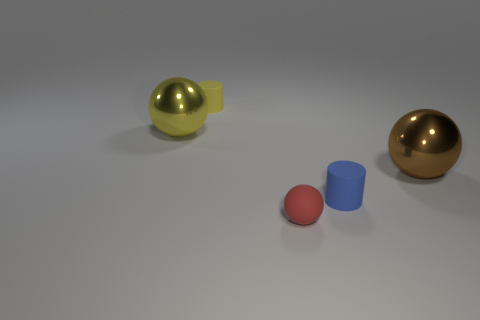Add 1 large metal things. How many objects exist? 6 Subtract all spheres. How many objects are left? 2 Subtract 0 gray cylinders. How many objects are left? 5 Subtract all small brown matte objects. Subtract all yellow matte cylinders. How many objects are left? 4 Add 4 shiny balls. How many shiny balls are left? 6 Add 3 big red metal cylinders. How many big red metal cylinders exist? 3 